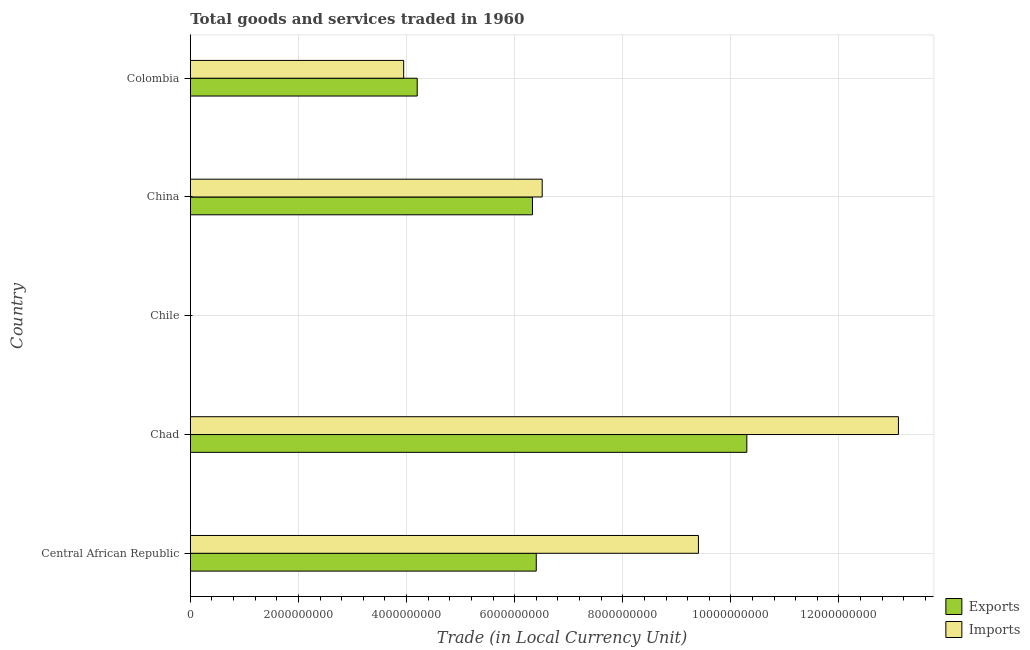How many groups of bars are there?
Provide a short and direct response. 5. Are the number of bars per tick equal to the number of legend labels?
Provide a short and direct response. Yes. Are the number of bars on each tick of the Y-axis equal?
Provide a succinct answer. Yes. What is the label of the 4th group of bars from the top?
Your response must be concise. Chad. What is the export of goods and services in Colombia?
Your answer should be very brief. 4.20e+09. Across all countries, what is the maximum imports of goods and services?
Your answer should be compact. 1.31e+1. Across all countries, what is the minimum export of goods and services?
Make the answer very short. 6.00e+05. In which country was the imports of goods and services maximum?
Ensure brevity in your answer.  Chad. In which country was the export of goods and services minimum?
Provide a succinct answer. Chile. What is the total imports of goods and services in the graph?
Ensure brevity in your answer.  3.30e+1. What is the difference between the imports of goods and services in Chile and that in China?
Ensure brevity in your answer.  -6.51e+09. What is the difference between the export of goods and services in Central African Republic and the imports of goods and services in Colombia?
Keep it short and to the point. 2.45e+09. What is the average imports of goods and services per country?
Your response must be concise. 6.59e+09. What is the difference between the imports of goods and services and export of goods and services in China?
Offer a very short reply. 1.80e+08. In how many countries, is the imports of goods and services greater than 10000000000 LCU?
Provide a short and direct response. 1. What is the ratio of the export of goods and services in Central African Republic to that in Chile?
Your answer should be compact. 1.07e+04. Is the imports of goods and services in Chile less than that in Colombia?
Make the answer very short. Yes. What is the difference between the highest and the second highest imports of goods and services?
Give a very brief answer. 3.70e+09. What is the difference between the highest and the lowest export of goods and services?
Ensure brevity in your answer.  1.03e+1. Is the sum of the imports of goods and services in China and Colombia greater than the maximum export of goods and services across all countries?
Offer a very short reply. Yes. What does the 1st bar from the top in Colombia represents?
Offer a very short reply. Imports. What does the 2nd bar from the bottom in Colombia represents?
Offer a terse response. Imports. What is the difference between two consecutive major ticks on the X-axis?
Provide a short and direct response. 2.00e+09. Are the values on the major ticks of X-axis written in scientific E-notation?
Make the answer very short. No. Does the graph contain any zero values?
Provide a succinct answer. No. Where does the legend appear in the graph?
Keep it short and to the point. Bottom right. How are the legend labels stacked?
Offer a very short reply. Vertical. What is the title of the graph?
Offer a terse response. Total goods and services traded in 1960. What is the label or title of the X-axis?
Your answer should be very brief. Trade (in Local Currency Unit). What is the label or title of the Y-axis?
Make the answer very short. Country. What is the Trade (in Local Currency Unit) of Exports in Central African Republic?
Provide a short and direct response. 6.40e+09. What is the Trade (in Local Currency Unit) in Imports in Central African Republic?
Your answer should be compact. 9.40e+09. What is the Trade (in Local Currency Unit) of Exports in Chad?
Keep it short and to the point. 1.03e+1. What is the Trade (in Local Currency Unit) of Imports in Chad?
Ensure brevity in your answer.  1.31e+1. What is the Trade (in Local Currency Unit) in Exports in Chile?
Provide a succinct answer. 6.00e+05. What is the Trade (in Local Currency Unit) of Imports in Chile?
Offer a terse response. 7.00e+05. What is the Trade (in Local Currency Unit) in Exports in China?
Your response must be concise. 6.33e+09. What is the Trade (in Local Currency Unit) of Imports in China?
Your answer should be very brief. 6.51e+09. What is the Trade (in Local Currency Unit) in Exports in Colombia?
Provide a succinct answer. 4.20e+09. What is the Trade (in Local Currency Unit) in Imports in Colombia?
Your answer should be compact. 3.95e+09. Across all countries, what is the maximum Trade (in Local Currency Unit) of Exports?
Provide a succinct answer. 1.03e+1. Across all countries, what is the maximum Trade (in Local Currency Unit) in Imports?
Ensure brevity in your answer.  1.31e+1. Across all countries, what is the minimum Trade (in Local Currency Unit) of Exports?
Ensure brevity in your answer.  6.00e+05. Across all countries, what is the minimum Trade (in Local Currency Unit) in Imports?
Your response must be concise. 7.00e+05. What is the total Trade (in Local Currency Unit) of Exports in the graph?
Offer a very short reply. 2.72e+1. What is the total Trade (in Local Currency Unit) of Imports in the graph?
Your answer should be very brief. 3.30e+1. What is the difference between the Trade (in Local Currency Unit) in Exports in Central African Republic and that in Chad?
Your response must be concise. -3.90e+09. What is the difference between the Trade (in Local Currency Unit) of Imports in Central African Republic and that in Chad?
Your response must be concise. -3.70e+09. What is the difference between the Trade (in Local Currency Unit) in Exports in Central African Republic and that in Chile?
Your answer should be very brief. 6.40e+09. What is the difference between the Trade (in Local Currency Unit) of Imports in Central African Republic and that in Chile?
Keep it short and to the point. 9.40e+09. What is the difference between the Trade (in Local Currency Unit) in Exports in Central African Republic and that in China?
Your answer should be very brief. 7.00e+07. What is the difference between the Trade (in Local Currency Unit) of Imports in Central African Republic and that in China?
Your answer should be compact. 2.89e+09. What is the difference between the Trade (in Local Currency Unit) in Exports in Central African Republic and that in Colombia?
Your answer should be compact. 2.20e+09. What is the difference between the Trade (in Local Currency Unit) in Imports in Central African Republic and that in Colombia?
Make the answer very short. 5.45e+09. What is the difference between the Trade (in Local Currency Unit) of Exports in Chad and that in Chile?
Your answer should be compact. 1.03e+1. What is the difference between the Trade (in Local Currency Unit) in Imports in Chad and that in Chile?
Provide a succinct answer. 1.31e+1. What is the difference between the Trade (in Local Currency Unit) of Exports in Chad and that in China?
Offer a terse response. 3.97e+09. What is the difference between the Trade (in Local Currency Unit) in Imports in Chad and that in China?
Your response must be concise. 6.59e+09. What is the difference between the Trade (in Local Currency Unit) in Exports in Chad and that in Colombia?
Your response must be concise. 6.10e+09. What is the difference between the Trade (in Local Currency Unit) of Imports in Chad and that in Colombia?
Give a very brief answer. 9.15e+09. What is the difference between the Trade (in Local Currency Unit) of Exports in Chile and that in China?
Your answer should be very brief. -6.33e+09. What is the difference between the Trade (in Local Currency Unit) of Imports in Chile and that in China?
Give a very brief answer. -6.51e+09. What is the difference between the Trade (in Local Currency Unit) of Exports in Chile and that in Colombia?
Make the answer very short. -4.20e+09. What is the difference between the Trade (in Local Currency Unit) in Imports in Chile and that in Colombia?
Keep it short and to the point. -3.95e+09. What is the difference between the Trade (in Local Currency Unit) in Exports in China and that in Colombia?
Your answer should be compact. 2.13e+09. What is the difference between the Trade (in Local Currency Unit) in Imports in China and that in Colombia?
Your answer should be compact. 2.56e+09. What is the difference between the Trade (in Local Currency Unit) of Exports in Central African Republic and the Trade (in Local Currency Unit) of Imports in Chad?
Offer a very short reply. -6.70e+09. What is the difference between the Trade (in Local Currency Unit) of Exports in Central African Republic and the Trade (in Local Currency Unit) of Imports in Chile?
Give a very brief answer. 6.40e+09. What is the difference between the Trade (in Local Currency Unit) in Exports in Central African Republic and the Trade (in Local Currency Unit) in Imports in China?
Give a very brief answer. -1.10e+08. What is the difference between the Trade (in Local Currency Unit) of Exports in Central African Republic and the Trade (in Local Currency Unit) of Imports in Colombia?
Provide a short and direct response. 2.45e+09. What is the difference between the Trade (in Local Currency Unit) in Exports in Chad and the Trade (in Local Currency Unit) in Imports in Chile?
Your answer should be compact. 1.03e+1. What is the difference between the Trade (in Local Currency Unit) in Exports in Chad and the Trade (in Local Currency Unit) in Imports in China?
Provide a succinct answer. 3.79e+09. What is the difference between the Trade (in Local Currency Unit) in Exports in Chad and the Trade (in Local Currency Unit) in Imports in Colombia?
Ensure brevity in your answer.  6.35e+09. What is the difference between the Trade (in Local Currency Unit) of Exports in Chile and the Trade (in Local Currency Unit) of Imports in China?
Your answer should be compact. -6.51e+09. What is the difference between the Trade (in Local Currency Unit) in Exports in Chile and the Trade (in Local Currency Unit) in Imports in Colombia?
Your answer should be very brief. -3.95e+09. What is the difference between the Trade (in Local Currency Unit) of Exports in China and the Trade (in Local Currency Unit) of Imports in Colombia?
Your response must be concise. 2.38e+09. What is the average Trade (in Local Currency Unit) in Exports per country?
Offer a terse response. 5.44e+09. What is the average Trade (in Local Currency Unit) of Imports per country?
Keep it short and to the point. 6.59e+09. What is the difference between the Trade (in Local Currency Unit) of Exports and Trade (in Local Currency Unit) of Imports in Central African Republic?
Your answer should be very brief. -3.00e+09. What is the difference between the Trade (in Local Currency Unit) in Exports and Trade (in Local Currency Unit) in Imports in Chad?
Offer a very short reply. -2.80e+09. What is the difference between the Trade (in Local Currency Unit) in Exports and Trade (in Local Currency Unit) in Imports in China?
Ensure brevity in your answer.  -1.80e+08. What is the difference between the Trade (in Local Currency Unit) in Exports and Trade (in Local Currency Unit) in Imports in Colombia?
Provide a short and direct response. 2.51e+08. What is the ratio of the Trade (in Local Currency Unit) in Exports in Central African Republic to that in Chad?
Keep it short and to the point. 0.62. What is the ratio of the Trade (in Local Currency Unit) of Imports in Central African Republic to that in Chad?
Make the answer very short. 0.72. What is the ratio of the Trade (in Local Currency Unit) in Exports in Central African Republic to that in Chile?
Provide a succinct answer. 1.07e+04. What is the ratio of the Trade (in Local Currency Unit) in Imports in Central African Republic to that in Chile?
Ensure brevity in your answer.  1.34e+04. What is the ratio of the Trade (in Local Currency Unit) in Exports in Central African Republic to that in China?
Your answer should be compact. 1.01. What is the ratio of the Trade (in Local Currency Unit) of Imports in Central African Republic to that in China?
Offer a terse response. 1.44. What is the ratio of the Trade (in Local Currency Unit) of Exports in Central African Republic to that in Colombia?
Give a very brief answer. 1.52. What is the ratio of the Trade (in Local Currency Unit) in Imports in Central African Republic to that in Colombia?
Make the answer very short. 2.38. What is the ratio of the Trade (in Local Currency Unit) in Exports in Chad to that in Chile?
Your answer should be compact. 1.72e+04. What is the ratio of the Trade (in Local Currency Unit) of Imports in Chad to that in Chile?
Provide a succinct answer. 1.87e+04. What is the ratio of the Trade (in Local Currency Unit) of Exports in Chad to that in China?
Give a very brief answer. 1.63. What is the ratio of the Trade (in Local Currency Unit) of Imports in Chad to that in China?
Provide a succinct answer. 2.01. What is the ratio of the Trade (in Local Currency Unit) of Exports in Chad to that in Colombia?
Offer a very short reply. 2.45. What is the ratio of the Trade (in Local Currency Unit) in Imports in Chad to that in Colombia?
Give a very brief answer. 3.32. What is the ratio of the Trade (in Local Currency Unit) of Imports in Chile to that in China?
Your answer should be compact. 0. What is the ratio of the Trade (in Local Currency Unit) of Imports in Chile to that in Colombia?
Your response must be concise. 0. What is the ratio of the Trade (in Local Currency Unit) of Exports in China to that in Colombia?
Your answer should be compact. 1.51. What is the ratio of the Trade (in Local Currency Unit) of Imports in China to that in Colombia?
Offer a very short reply. 1.65. What is the difference between the highest and the second highest Trade (in Local Currency Unit) of Exports?
Your answer should be compact. 3.90e+09. What is the difference between the highest and the second highest Trade (in Local Currency Unit) in Imports?
Your response must be concise. 3.70e+09. What is the difference between the highest and the lowest Trade (in Local Currency Unit) of Exports?
Make the answer very short. 1.03e+1. What is the difference between the highest and the lowest Trade (in Local Currency Unit) of Imports?
Keep it short and to the point. 1.31e+1. 